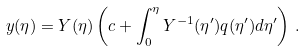Convert formula to latex. <formula><loc_0><loc_0><loc_500><loc_500>y ( \eta ) = Y ( \eta ) \left ( c + \int _ { 0 } ^ { \eta } Y ^ { - 1 } ( \eta ^ { \prime } ) q ( \eta ^ { \prime } ) d \eta ^ { \prime } \right ) \, .</formula> 